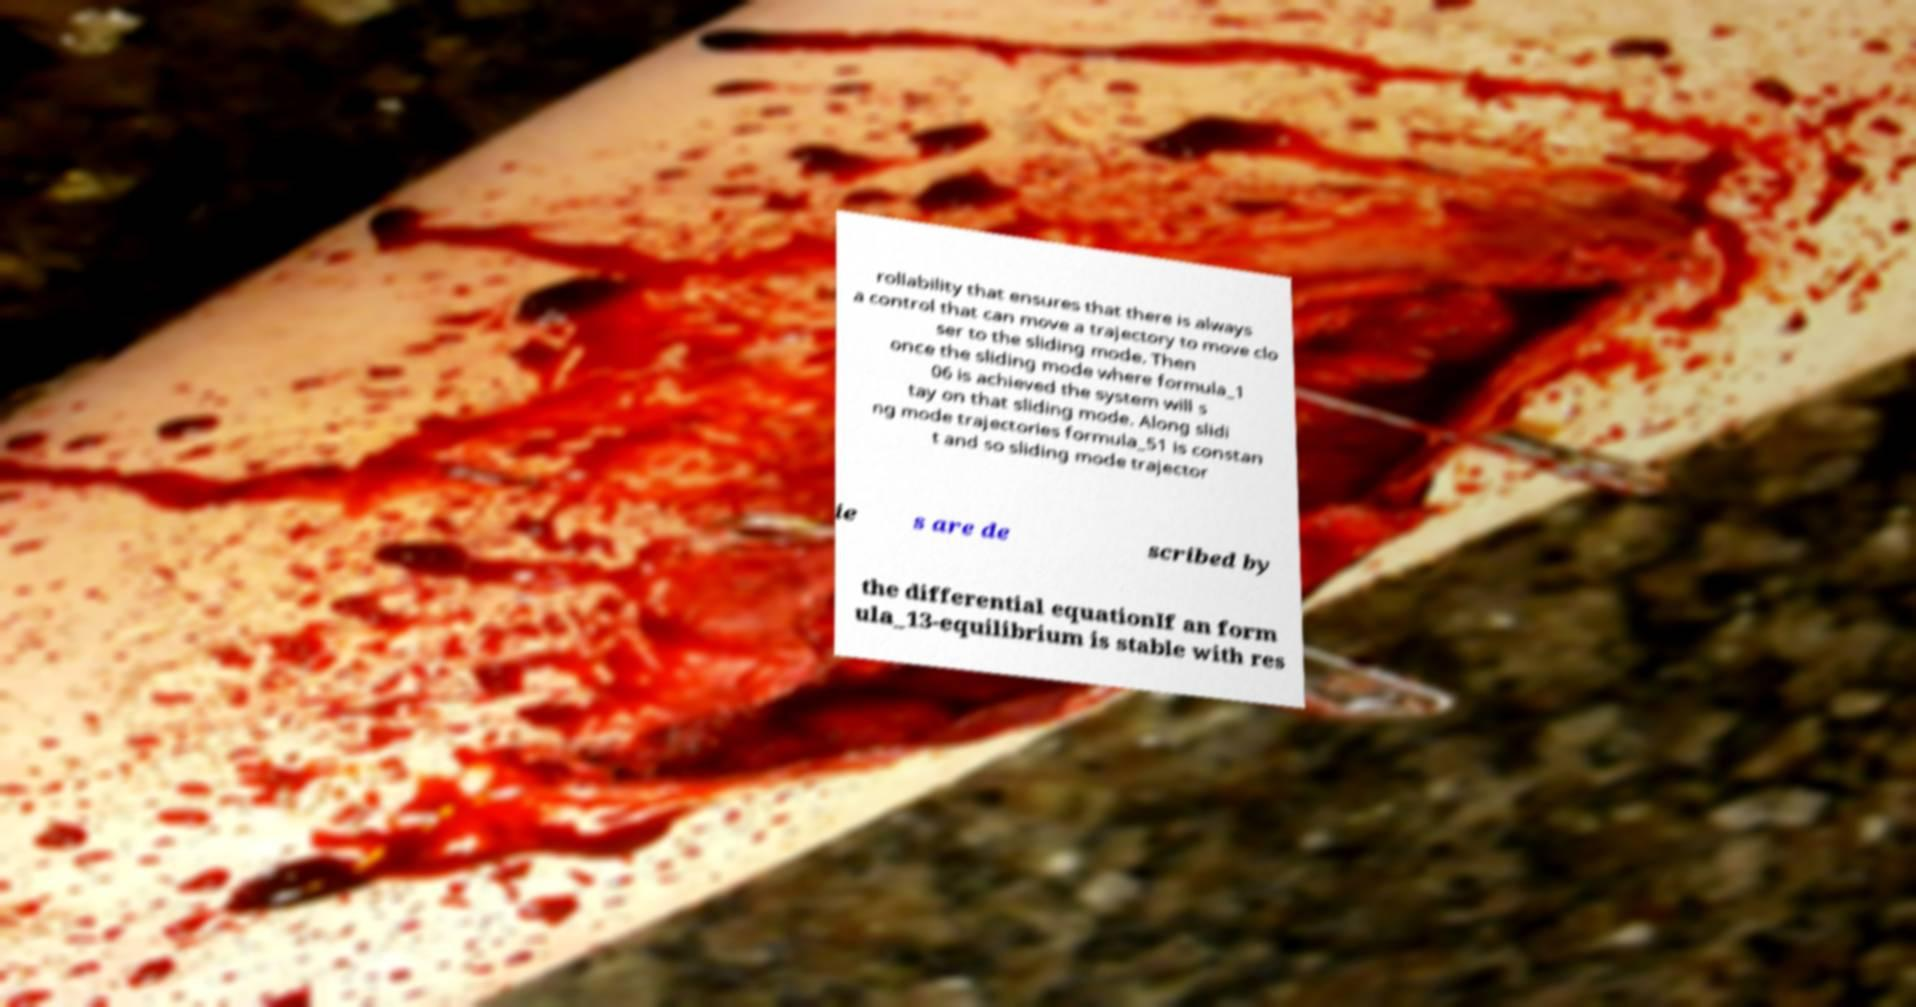Please identify and transcribe the text found in this image. rollability that ensures that there is always a control that can move a trajectory to move clo ser to the sliding mode. Then once the sliding mode where formula_1 06 is achieved the system will s tay on that sliding mode. Along slidi ng mode trajectories formula_51 is constan t and so sliding mode trajector ie s are de scribed by the differential equationIf an form ula_13-equilibrium is stable with res 